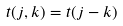Convert formula to latex. <formula><loc_0><loc_0><loc_500><loc_500>t ( j , k ) = t ( j - k )</formula> 